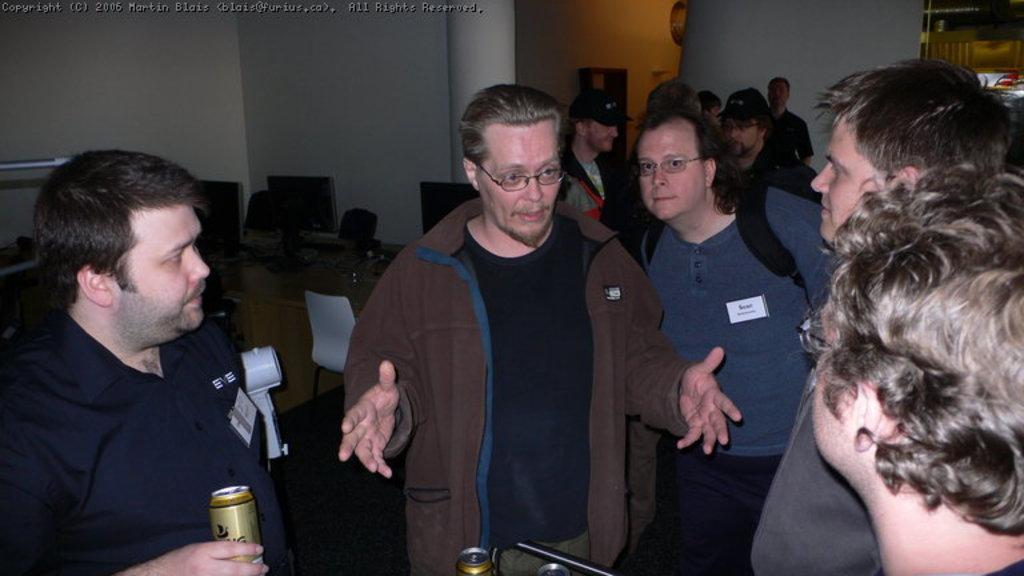Please provide a concise description of this image. In the center of the image there are people standing. In the background of the image there is a wall. There is a pillar. There is a table on which there are monitors and other objects. There is a white color chair. To the left side of the image there is a person holding a tin in his hand. 